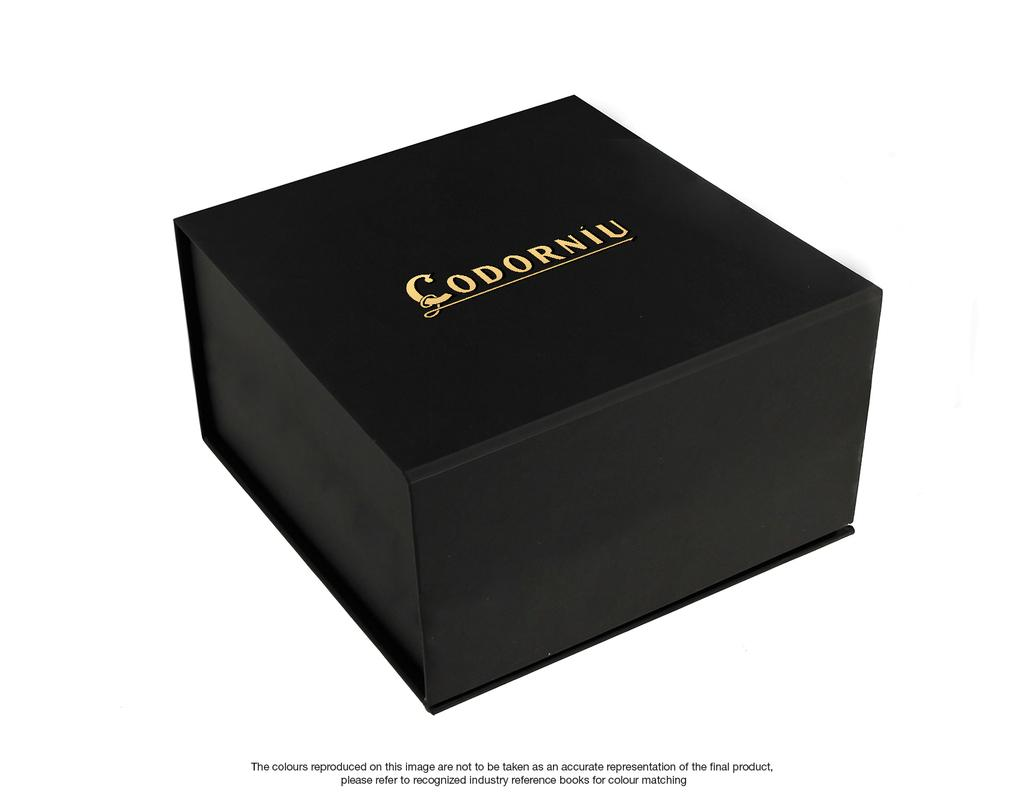<image>
Describe the image concisely. A black decorative packaging for something called Codorniu with gold lettering. 